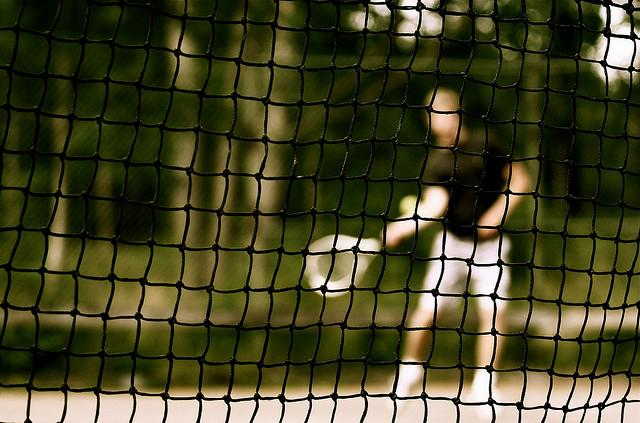This person is playing a similar sport to whom? serena williams 